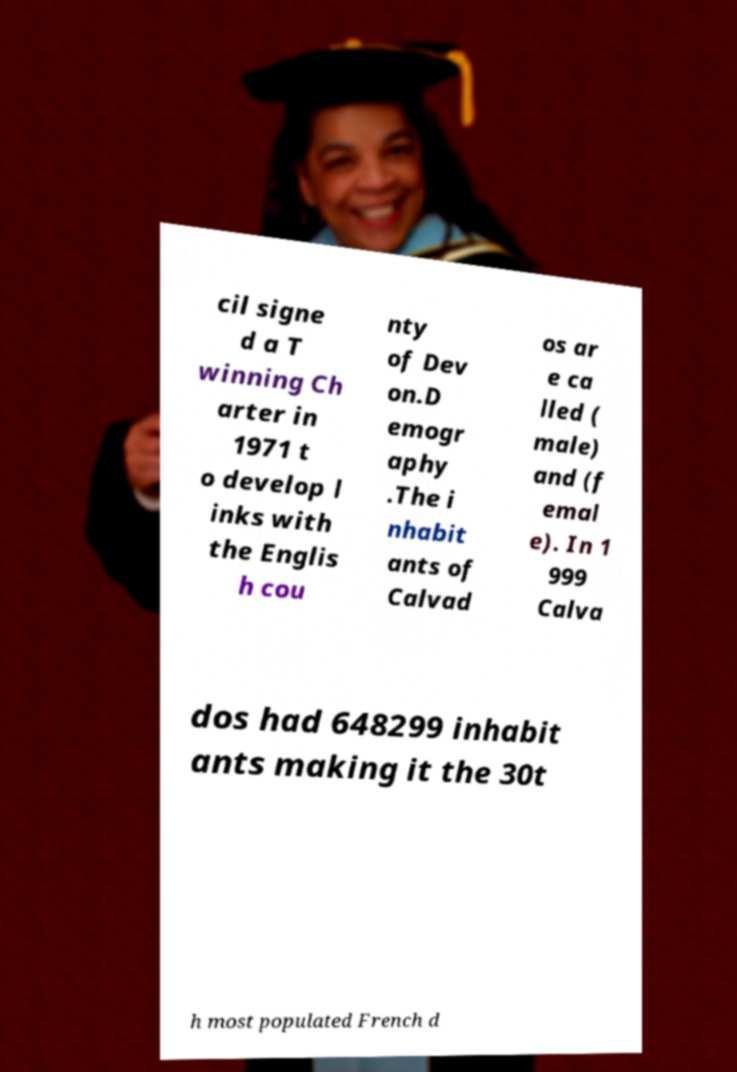What messages or text are displayed in this image? I need them in a readable, typed format. cil signe d a T winning Ch arter in 1971 t o develop l inks with the Englis h cou nty of Dev on.D emogr aphy .The i nhabit ants of Calvad os ar e ca lled ( male) and (f emal e). In 1 999 Calva dos had 648299 inhabit ants making it the 30t h most populated French d 